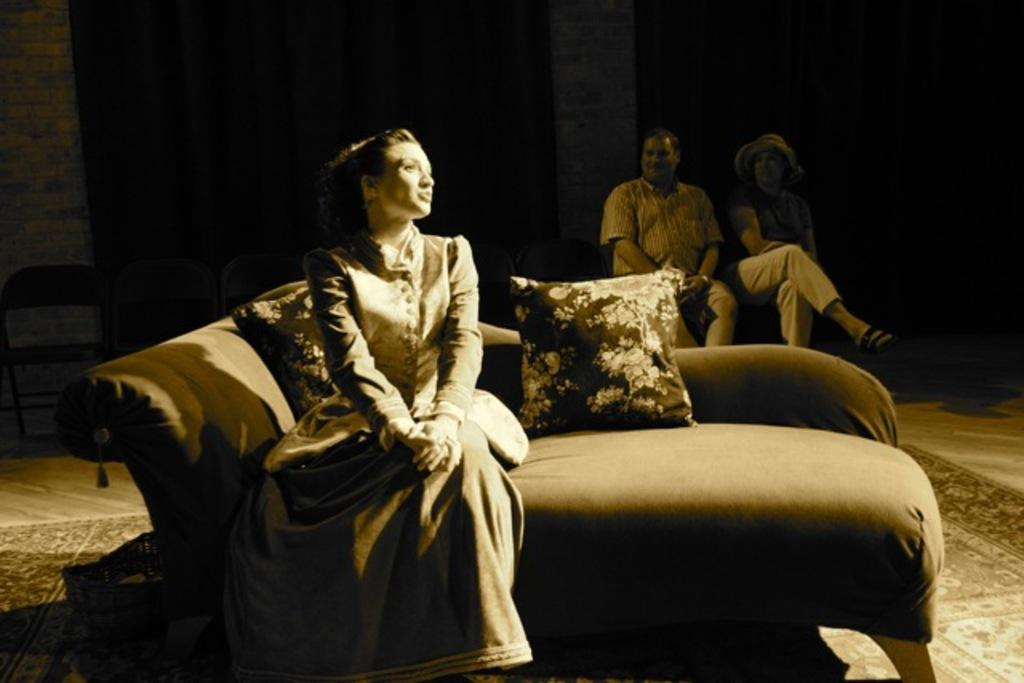What is the woman in the image doing? The woman is sitting on a sofa in the image. What can be seen on the sofa besides the woman? There are pillows on the sofa. Are there any other people visible in the image? Yes, there are two persons on the right side of the image. What is the name of the woman's daughter in the image? There is no mention of a daughter or any other family members in the image. 